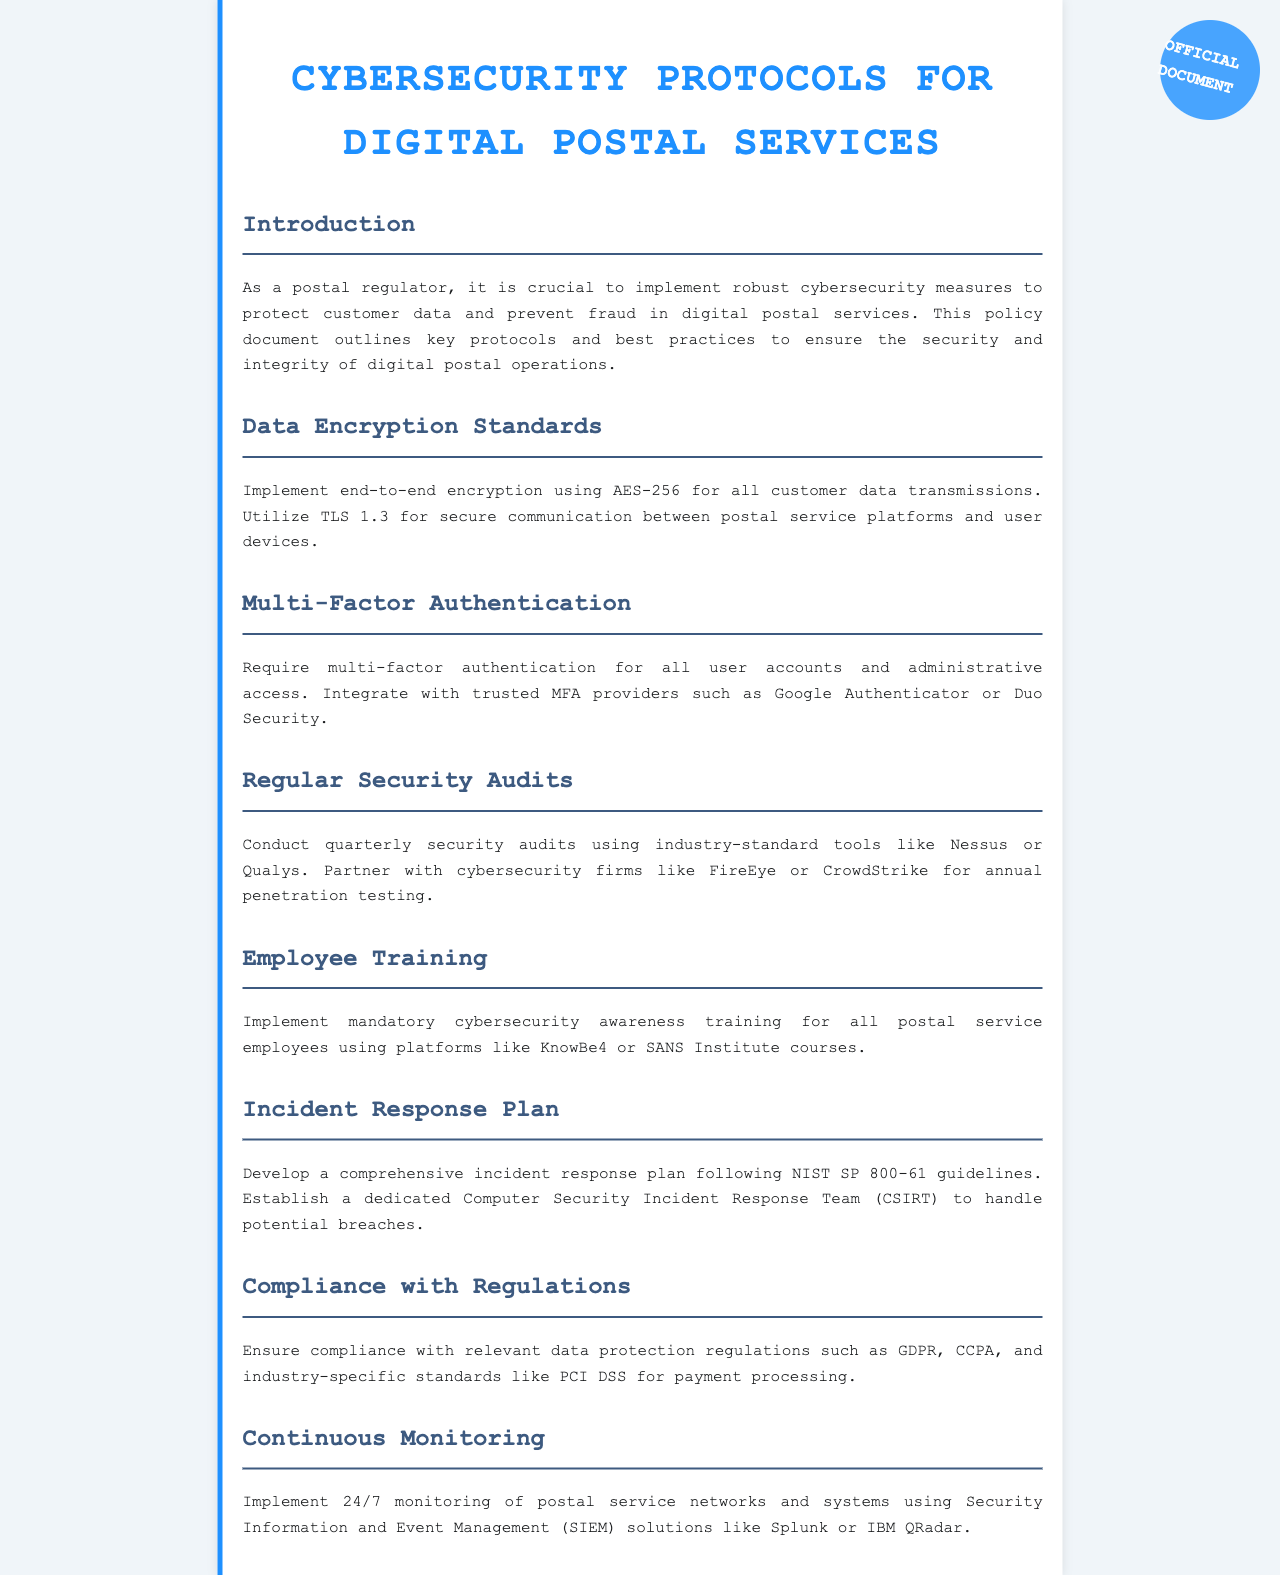What encryption standard is recommended? The document states that end-to-end encryption should use AES-256 for all customer data transmissions.
Answer: AES-256 What is required for user accounts? The document declares that multi-factor authentication is required for all user accounts and administrative access.
Answer: Multi-factor authentication How often should security audits be conducted? According to the document, security audits should be conducted quarterly.
Answer: Quarterly What guidelines should the incident response plan follow? The document specifies that the incident response plan should follow NIST SP 800-61 guidelines.
Answer: NIST SP 800-61 What is the purpose of cybersecurity awareness training? The document mentions that the purpose of cybersecurity awareness training is to educate all postal service employees about security protocols.
Answer: Educate employees Which solutions are suggested for continuous monitoring? The document recommends using Security Information and Event Management (SIEM) solutions like Splunk or IBM QRadar for continuous monitoring.
Answer: Splunk or IBM QRadar What regulations must be complied with? The document states that compliance must be ensured with regulations such as GDPR and CCPA.
Answer: GDPR and CCPA Who should be involved in annual penetration testing? The document advises partnering with cybersecurity firms like FireEye or CrowdStrike for annual penetration testing.
Answer: FireEye or CrowdStrike 